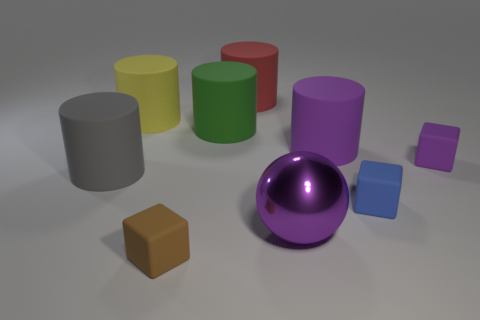Are there any other things that have the same material as the big ball?
Give a very brief answer. No. Is the material of the green cylinder the same as the large ball?
Your answer should be compact. No. What number of big shiny spheres are on the left side of the sphere?
Provide a short and direct response. 0. There is a blue thing that is the same shape as the tiny purple rubber object; what is its size?
Ensure brevity in your answer.  Small. What number of red objects are either large matte cylinders or big spheres?
Your answer should be compact. 1. There is a tiny matte object left of the red cylinder; how many rubber blocks are to the right of it?
Make the answer very short. 2. What number of other things are the same shape as the big yellow thing?
Keep it short and to the point. 4. There is a cube that is the same color as the metal thing; what is its material?
Provide a succinct answer. Rubber. How many other large objects have the same color as the large metal thing?
Ensure brevity in your answer.  1. Are there any red rubber cylinders of the same size as the brown block?
Offer a very short reply. No. 